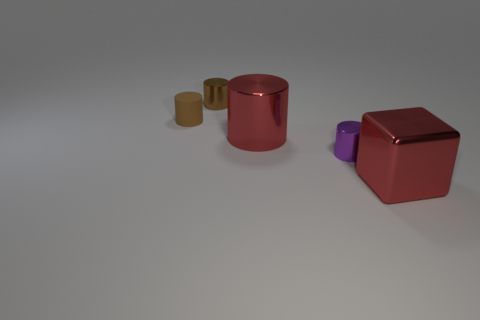Are there fewer matte things that are in front of the tiny matte cylinder than big red rubber spheres? There appears to be one tiny matte cylinder and two large glossy spheres, one of which is red. Since the question pertains to matte objects in front of the cylinder and big red rubber spheres, it’s important to note that no matte objects are in front of the cylinder. Also, there are no red rubber spheres; rather, there's one large red glossy sphere. Thus, we cannot compare the count of matte objects in front of the cylinder to red rubber spheres, as there are none. 